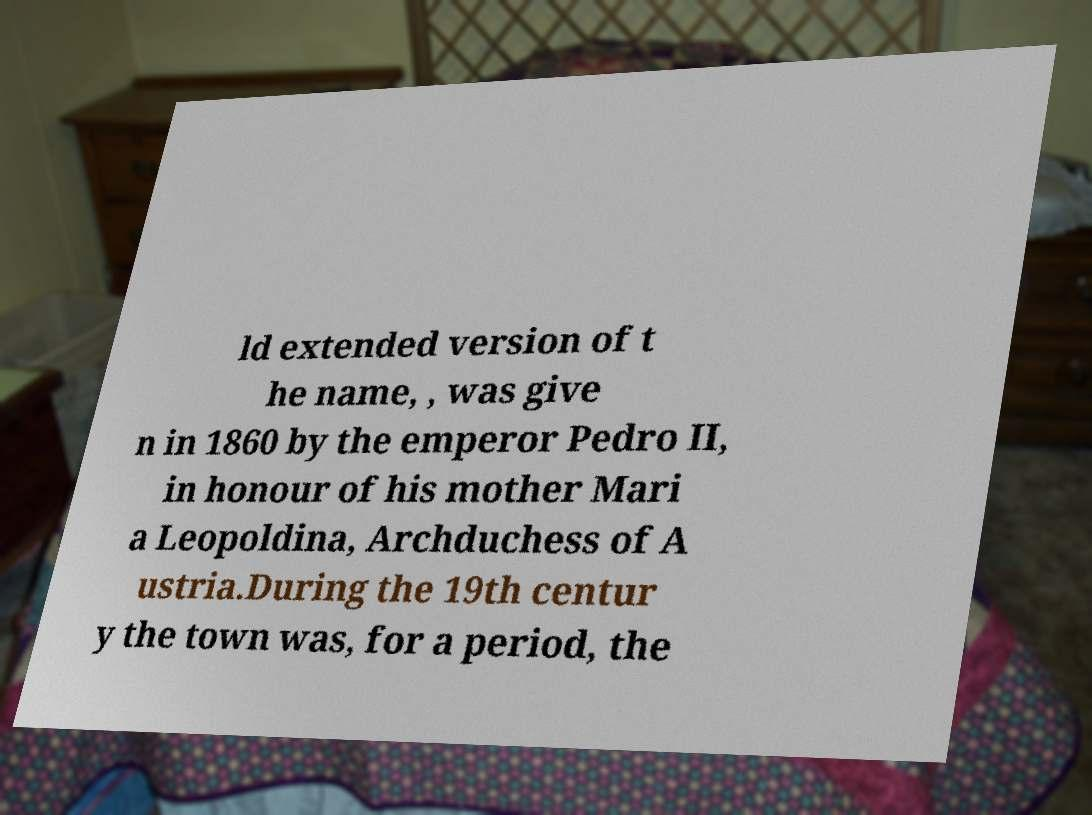What messages or text are displayed in this image? I need them in a readable, typed format. ld extended version of t he name, , was give n in 1860 by the emperor Pedro II, in honour of his mother Mari a Leopoldina, Archduchess of A ustria.During the 19th centur y the town was, for a period, the 